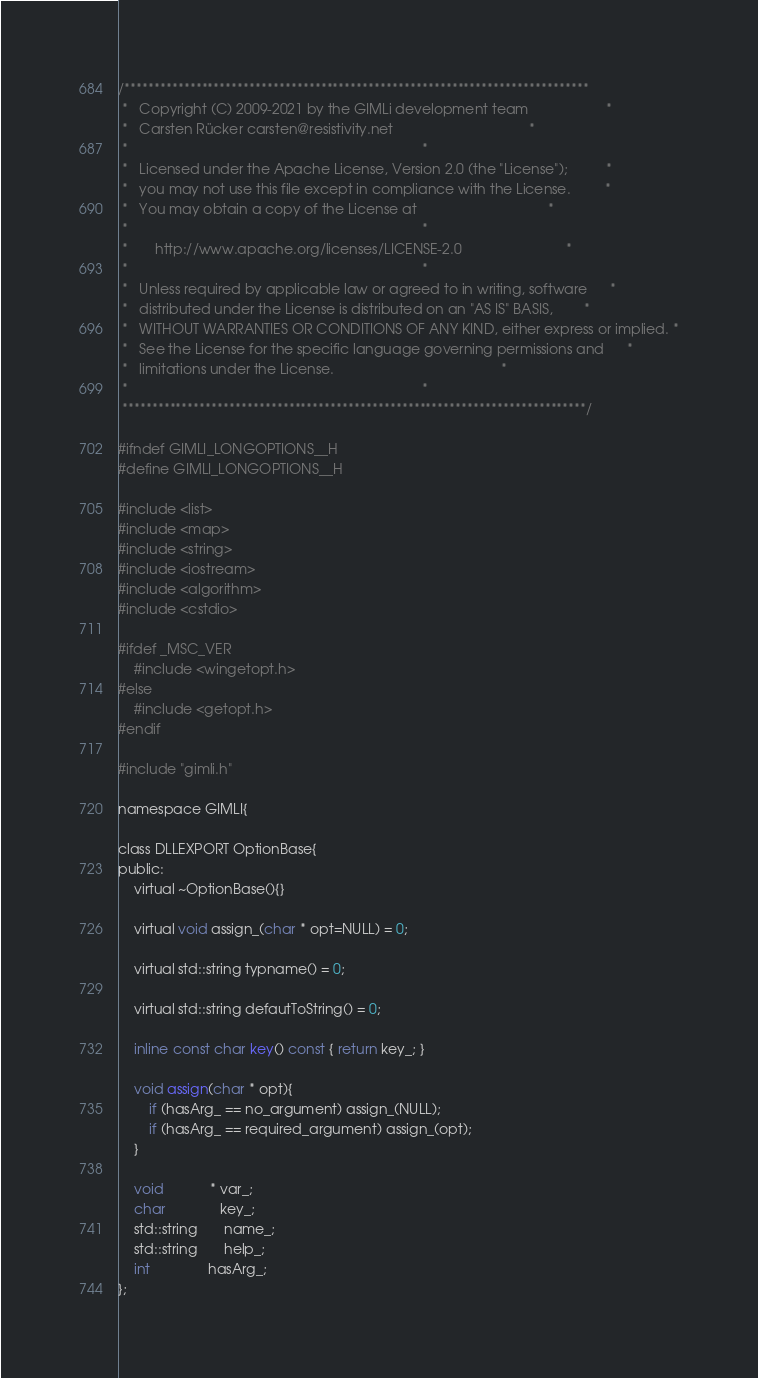<code> <loc_0><loc_0><loc_500><loc_500><_C_>/******************************************************************************
 *   Copyright (C) 2009-2021 by the GIMLi development team                    *
 *   Carsten Rücker carsten@resistivity.net                                   *
 *                                                                            *
 *   Licensed under the Apache License, Version 2.0 (the "License");          *
 *   you may not use this file except in compliance with the License.         *
 *   You may obtain a copy of the License at                                  *
 *                                                                            *
 *       http://www.apache.org/licenses/LICENSE-2.0                           *
 *                                                                            *
 *   Unless required by applicable law or agreed to in writing, software      *
 *   distributed under the License is distributed on an "AS IS" BASIS,        *
 *   WITHOUT WARRANTIES OR CONDITIONS OF ANY KIND, either express or implied. *
 *   See the License for the specific language governing permissions and      *
 *   limitations under the License.                                           *
 *                                                                            *
 ******************************************************************************/

#ifndef GIMLI_LONGOPTIONS__H
#define GIMLI_LONGOPTIONS__H

#include <list>
#include <map>
#include <string>
#include <iostream>
#include <algorithm>
#include <cstdio>

#ifdef _MSC_VER
	#include <wingetopt.h>
#else
	#include <getopt.h>
#endif

#include "gimli.h"

namespace GIMLI{

class DLLEXPORT OptionBase{
public:
    virtual ~OptionBase(){}

    virtual void assign_(char * opt=NULL) = 0;

    virtual std::string typname() = 0;

    virtual std::string defautToString() = 0;

    inline const char key() const { return key_; }

    void assign(char * opt){
        if (hasArg_ == no_argument) assign_(NULL);
        if (hasArg_ == required_argument) assign_(opt);
    }

    void            * var_;
    char              key_;
    std::string       name_;
    std::string       help_;
    int               hasArg_;
};
</code> 